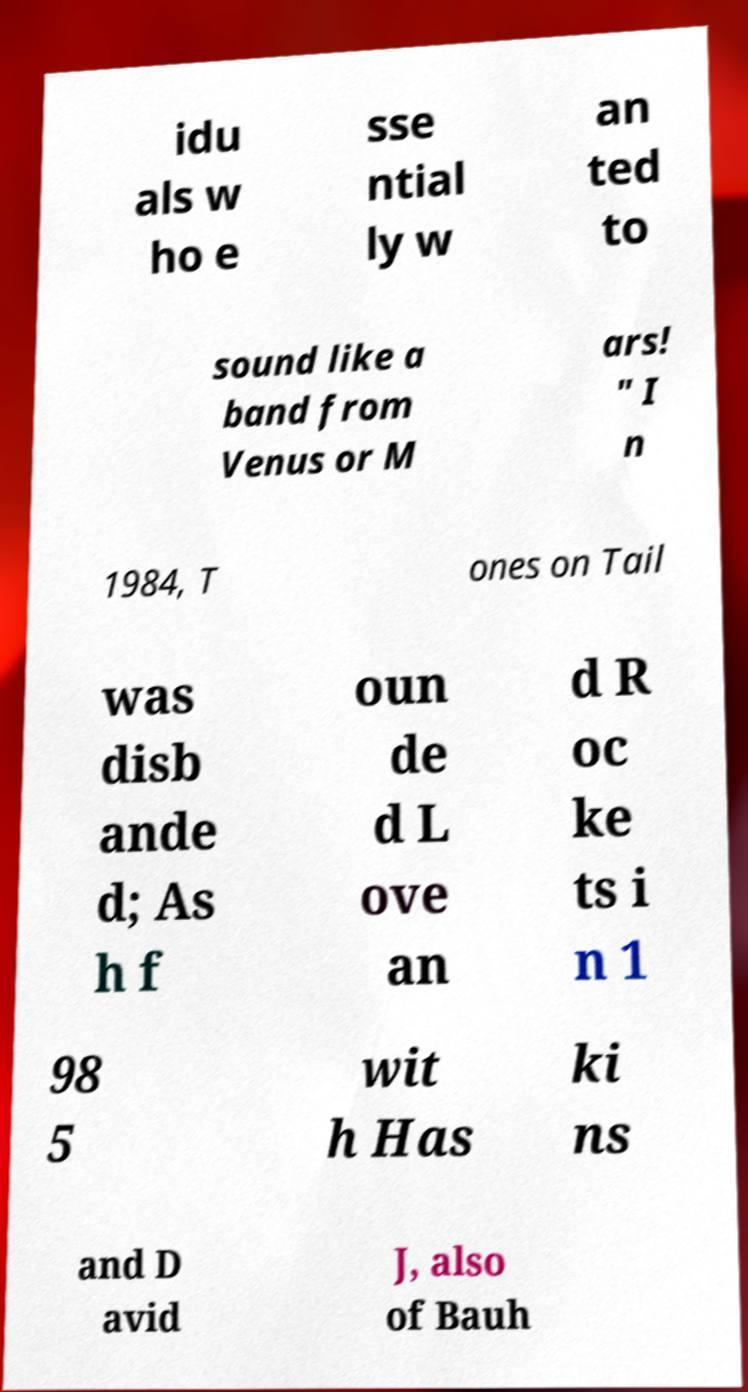Please identify and transcribe the text found in this image. idu als w ho e sse ntial ly w an ted to sound like a band from Venus or M ars! " I n 1984, T ones on Tail was disb ande d; As h f oun de d L ove an d R oc ke ts i n 1 98 5 wit h Has ki ns and D avid J, also of Bauh 